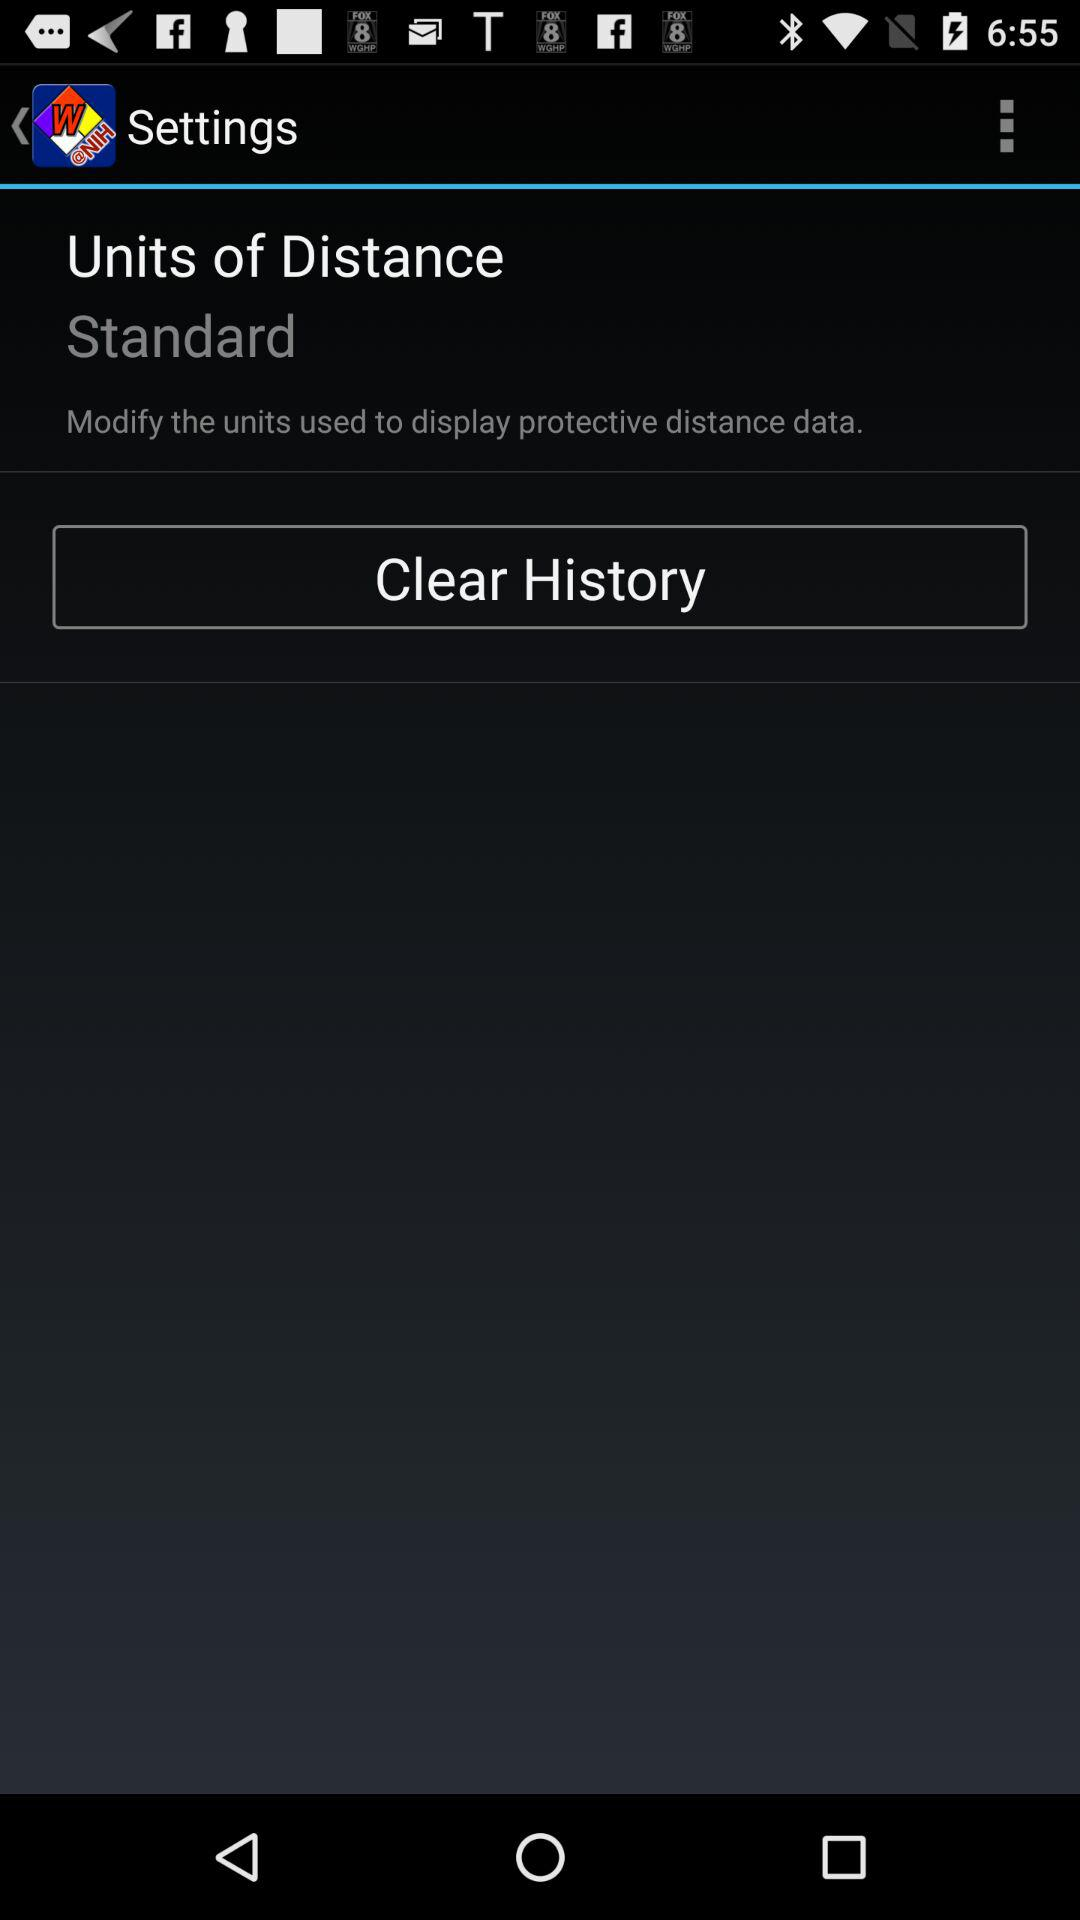What is the selected unit of distance? The selected unit of distance is standard. 